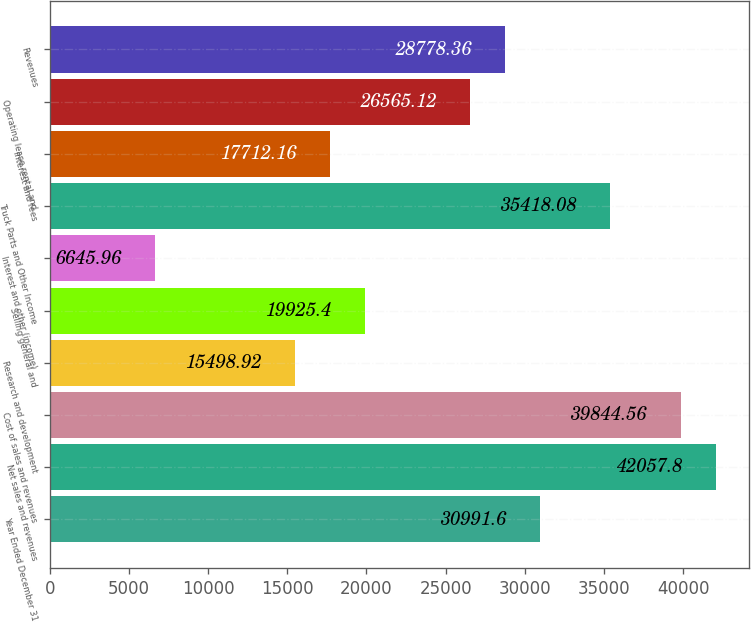<chart> <loc_0><loc_0><loc_500><loc_500><bar_chart><fcel>Year Ended December 31<fcel>Net sales and revenues<fcel>Cost of sales and revenues<fcel>Research and development<fcel>Selling general and<fcel>Interest and other (income)<fcel>Truck Parts and Other Income<fcel>Interest and fees<fcel>Operating lease rental and<fcel>Revenues<nl><fcel>30991.6<fcel>42057.8<fcel>39844.6<fcel>15498.9<fcel>19925.4<fcel>6645.96<fcel>35418.1<fcel>17712.2<fcel>26565.1<fcel>28778.4<nl></chart> 